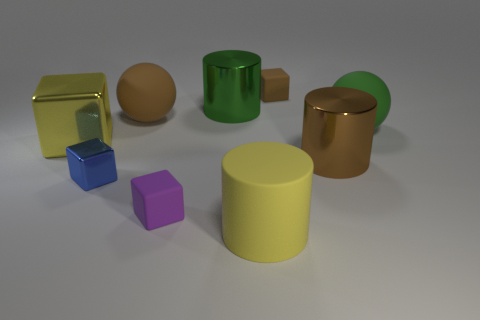Does this image look like it represents a realistic environment? Not quite; the objects appear to be more illustrative or conceptual, possibly part of a 3D rendering or a simulation. The uniform background and perfect shapes give it away. 